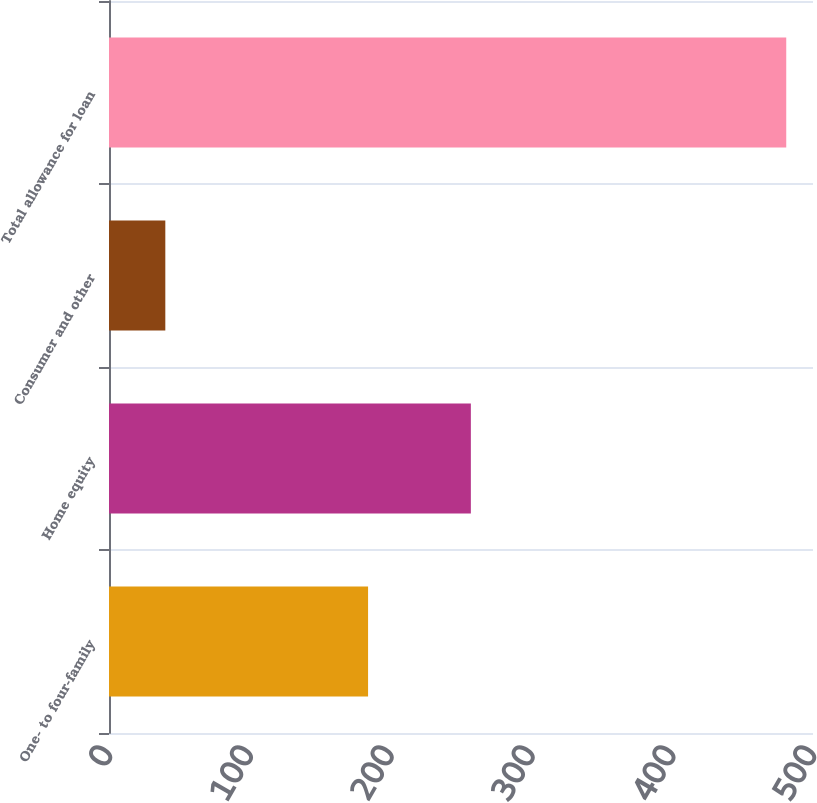<chart> <loc_0><loc_0><loc_500><loc_500><bar_chart><fcel>One- to four-family<fcel>Home equity<fcel>Consumer and other<fcel>Total allowance for loan<nl><fcel>184<fcel>257<fcel>40<fcel>481<nl></chart> 